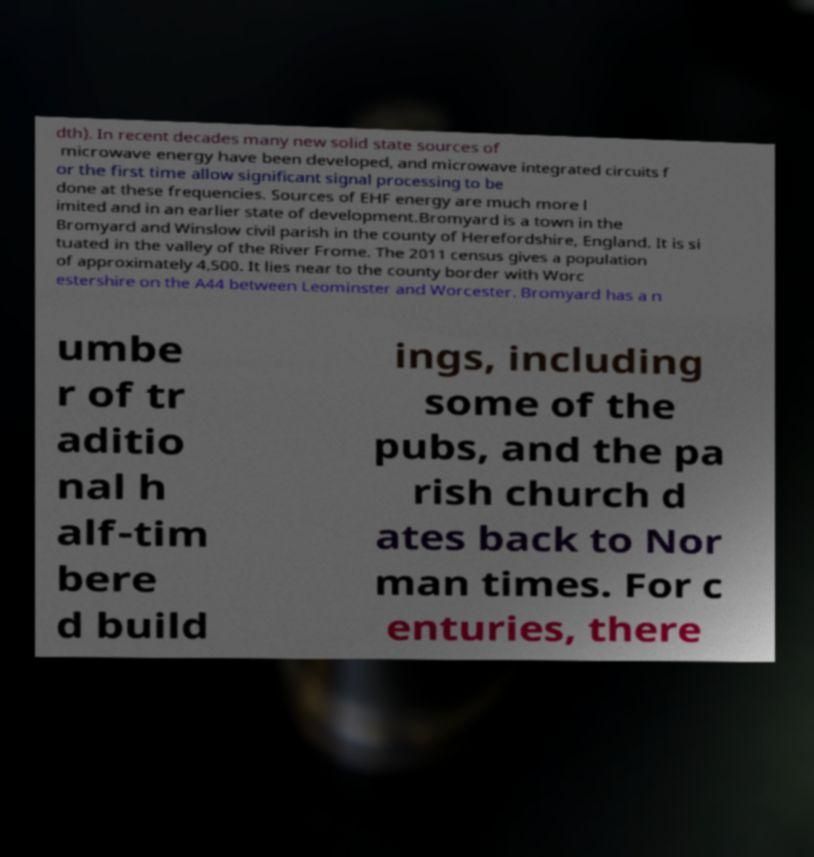Could you assist in decoding the text presented in this image and type it out clearly? dth). In recent decades many new solid state sources of microwave energy have been developed, and microwave integrated circuits f or the first time allow significant signal processing to be done at these frequencies. Sources of EHF energy are much more l imited and in an earlier state of development.Bromyard is a town in the Bromyard and Winslow civil parish in the county of Herefordshire, England. It is si tuated in the valley of the River Frome. The 2011 census gives a population of approximately 4,500. It lies near to the county border with Worc estershire on the A44 between Leominster and Worcester. Bromyard has a n umbe r of tr aditio nal h alf-tim bere d build ings, including some of the pubs, and the pa rish church d ates back to Nor man times. For c enturies, there 